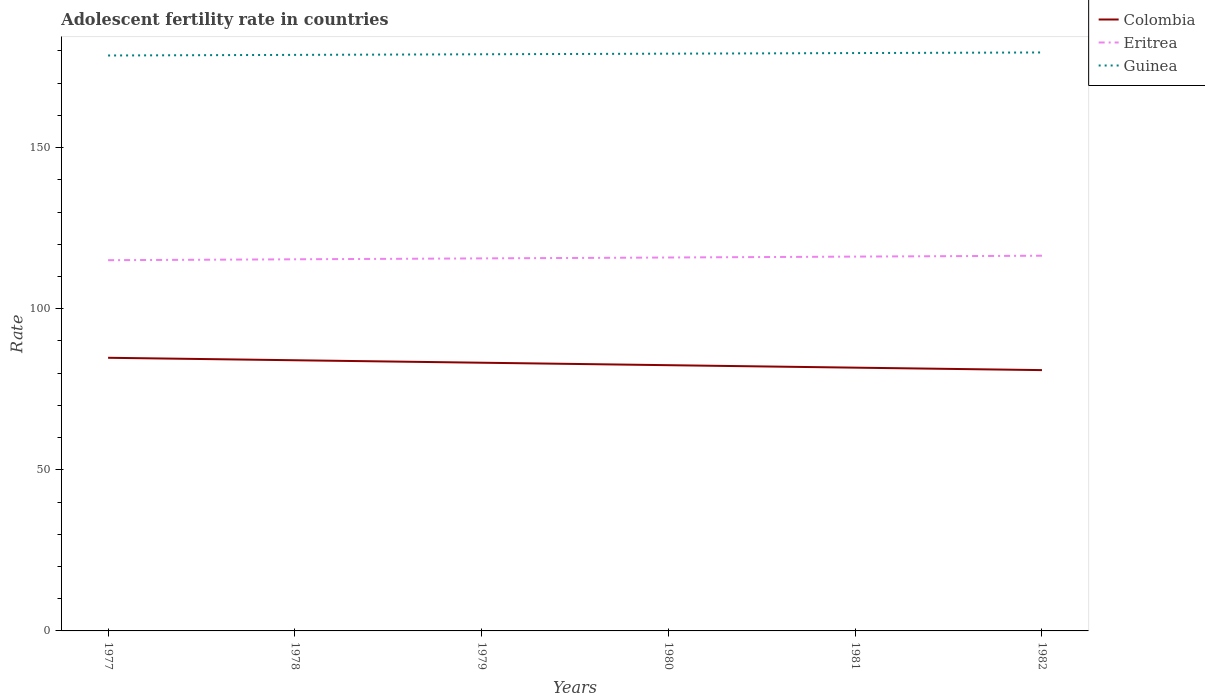How many different coloured lines are there?
Your response must be concise. 3. Does the line corresponding to Eritrea intersect with the line corresponding to Guinea?
Your answer should be very brief. No. Is the number of lines equal to the number of legend labels?
Provide a short and direct response. Yes. Across all years, what is the maximum adolescent fertility rate in Eritrea?
Your answer should be compact. 115.06. What is the total adolescent fertility rate in Colombia in the graph?
Give a very brief answer. 2.3. What is the difference between the highest and the second highest adolescent fertility rate in Guinea?
Keep it short and to the point. 0.94. Is the adolescent fertility rate in Colombia strictly greater than the adolescent fertility rate in Guinea over the years?
Offer a very short reply. Yes. Does the graph contain any zero values?
Offer a terse response. No. How many legend labels are there?
Provide a short and direct response. 3. How are the legend labels stacked?
Offer a terse response. Vertical. What is the title of the graph?
Your answer should be very brief. Adolescent fertility rate in countries. What is the label or title of the X-axis?
Keep it short and to the point. Years. What is the label or title of the Y-axis?
Ensure brevity in your answer.  Rate. What is the Rate in Colombia in 1977?
Make the answer very short. 84.77. What is the Rate in Eritrea in 1977?
Your answer should be very brief. 115.06. What is the Rate in Guinea in 1977?
Your answer should be compact. 178.59. What is the Rate of Colombia in 1978?
Your answer should be very brief. 84. What is the Rate in Eritrea in 1978?
Your response must be concise. 115.33. What is the Rate of Guinea in 1978?
Keep it short and to the point. 178.77. What is the Rate in Colombia in 1979?
Provide a short and direct response. 83.24. What is the Rate of Eritrea in 1979?
Your answer should be very brief. 115.61. What is the Rate of Guinea in 1979?
Your answer should be very brief. 178.96. What is the Rate in Colombia in 1980?
Keep it short and to the point. 82.47. What is the Rate of Eritrea in 1980?
Offer a very short reply. 115.89. What is the Rate of Guinea in 1980?
Provide a short and direct response. 179.15. What is the Rate of Colombia in 1981?
Ensure brevity in your answer.  81.71. What is the Rate in Eritrea in 1981?
Your response must be concise. 116.17. What is the Rate in Guinea in 1981?
Provide a short and direct response. 179.34. What is the Rate in Colombia in 1982?
Provide a short and direct response. 80.94. What is the Rate in Eritrea in 1982?
Provide a short and direct response. 116.45. What is the Rate in Guinea in 1982?
Provide a short and direct response. 179.52. Across all years, what is the maximum Rate in Colombia?
Offer a terse response. 84.77. Across all years, what is the maximum Rate of Eritrea?
Your answer should be compact. 116.45. Across all years, what is the maximum Rate of Guinea?
Offer a very short reply. 179.52. Across all years, what is the minimum Rate of Colombia?
Ensure brevity in your answer.  80.94. Across all years, what is the minimum Rate of Eritrea?
Your answer should be very brief. 115.06. Across all years, what is the minimum Rate in Guinea?
Your answer should be compact. 178.59. What is the total Rate in Colombia in the graph?
Make the answer very short. 497.12. What is the total Rate of Eritrea in the graph?
Offer a terse response. 694.51. What is the total Rate of Guinea in the graph?
Make the answer very short. 1074.33. What is the difference between the Rate of Colombia in 1977 and that in 1978?
Offer a very short reply. 0.77. What is the difference between the Rate in Eritrea in 1977 and that in 1978?
Give a very brief answer. -0.28. What is the difference between the Rate of Guinea in 1977 and that in 1978?
Your answer should be compact. -0.19. What is the difference between the Rate of Colombia in 1977 and that in 1979?
Offer a terse response. 1.53. What is the difference between the Rate of Eritrea in 1977 and that in 1979?
Provide a short and direct response. -0.56. What is the difference between the Rate of Guinea in 1977 and that in 1979?
Offer a terse response. -0.38. What is the difference between the Rate of Colombia in 1977 and that in 1980?
Your answer should be compact. 2.3. What is the difference between the Rate in Eritrea in 1977 and that in 1980?
Give a very brief answer. -0.83. What is the difference between the Rate of Guinea in 1977 and that in 1980?
Provide a succinct answer. -0.56. What is the difference between the Rate of Colombia in 1977 and that in 1981?
Offer a terse response. 3.06. What is the difference between the Rate in Eritrea in 1977 and that in 1981?
Make the answer very short. -1.11. What is the difference between the Rate in Guinea in 1977 and that in 1981?
Offer a very short reply. -0.75. What is the difference between the Rate of Colombia in 1977 and that in 1982?
Give a very brief answer. 3.83. What is the difference between the Rate in Eritrea in 1977 and that in 1982?
Keep it short and to the point. -1.39. What is the difference between the Rate of Guinea in 1977 and that in 1982?
Offer a terse response. -0.94. What is the difference between the Rate of Colombia in 1978 and that in 1979?
Offer a very short reply. 0.77. What is the difference between the Rate in Eritrea in 1978 and that in 1979?
Provide a short and direct response. -0.28. What is the difference between the Rate of Guinea in 1978 and that in 1979?
Your answer should be compact. -0.19. What is the difference between the Rate in Colombia in 1978 and that in 1980?
Give a very brief answer. 1.53. What is the difference between the Rate of Eritrea in 1978 and that in 1980?
Provide a short and direct response. -0.56. What is the difference between the Rate in Guinea in 1978 and that in 1980?
Your answer should be compact. -0.38. What is the difference between the Rate in Colombia in 1978 and that in 1981?
Ensure brevity in your answer.  2.3. What is the difference between the Rate of Eritrea in 1978 and that in 1981?
Ensure brevity in your answer.  -0.83. What is the difference between the Rate of Guinea in 1978 and that in 1981?
Your answer should be compact. -0.56. What is the difference between the Rate in Colombia in 1978 and that in 1982?
Give a very brief answer. 3.06. What is the difference between the Rate in Eritrea in 1978 and that in 1982?
Keep it short and to the point. -1.11. What is the difference between the Rate of Guinea in 1978 and that in 1982?
Offer a very short reply. -0.75. What is the difference between the Rate of Colombia in 1979 and that in 1980?
Offer a terse response. 0.77. What is the difference between the Rate of Eritrea in 1979 and that in 1980?
Provide a succinct answer. -0.28. What is the difference between the Rate in Guinea in 1979 and that in 1980?
Offer a terse response. -0.19. What is the difference between the Rate of Colombia in 1979 and that in 1981?
Offer a very short reply. 1.53. What is the difference between the Rate in Eritrea in 1979 and that in 1981?
Make the answer very short. -0.56. What is the difference between the Rate of Guinea in 1979 and that in 1981?
Your response must be concise. -0.38. What is the difference between the Rate in Colombia in 1979 and that in 1982?
Offer a very short reply. 2.3. What is the difference between the Rate of Eritrea in 1979 and that in 1982?
Provide a succinct answer. -0.83. What is the difference between the Rate of Guinea in 1979 and that in 1982?
Make the answer very short. -0.56. What is the difference between the Rate in Colombia in 1980 and that in 1981?
Offer a very short reply. 0.77. What is the difference between the Rate of Eritrea in 1980 and that in 1981?
Provide a short and direct response. -0.28. What is the difference between the Rate of Guinea in 1980 and that in 1981?
Your answer should be compact. -0.19. What is the difference between the Rate of Colombia in 1980 and that in 1982?
Offer a very short reply. 1.53. What is the difference between the Rate in Eritrea in 1980 and that in 1982?
Give a very brief answer. -0.56. What is the difference between the Rate in Guinea in 1980 and that in 1982?
Offer a very short reply. -0.38. What is the difference between the Rate of Colombia in 1981 and that in 1982?
Keep it short and to the point. 0.77. What is the difference between the Rate of Eritrea in 1981 and that in 1982?
Give a very brief answer. -0.28. What is the difference between the Rate of Guinea in 1981 and that in 1982?
Keep it short and to the point. -0.19. What is the difference between the Rate of Colombia in 1977 and the Rate of Eritrea in 1978?
Your response must be concise. -30.57. What is the difference between the Rate in Colombia in 1977 and the Rate in Guinea in 1978?
Give a very brief answer. -94.01. What is the difference between the Rate in Eritrea in 1977 and the Rate in Guinea in 1978?
Make the answer very short. -63.72. What is the difference between the Rate of Colombia in 1977 and the Rate of Eritrea in 1979?
Your response must be concise. -30.84. What is the difference between the Rate in Colombia in 1977 and the Rate in Guinea in 1979?
Make the answer very short. -94.19. What is the difference between the Rate in Eritrea in 1977 and the Rate in Guinea in 1979?
Offer a terse response. -63.9. What is the difference between the Rate of Colombia in 1977 and the Rate of Eritrea in 1980?
Keep it short and to the point. -31.12. What is the difference between the Rate in Colombia in 1977 and the Rate in Guinea in 1980?
Offer a very short reply. -94.38. What is the difference between the Rate of Eritrea in 1977 and the Rate of Guinea in 1980?
Offer a very short reply. -64.09. What is the difference between the Rate in Colombia in 1977 and the Rate in Eritrea in 1981?
Your answer should be compact. -31.4. What is the difference between the Rate in Colombia in 1977 and the Rate in Guinea in 1981?
Keep it short and to the point. -94.57. What is the difference between the Rate in Eritrea in 1977 and the Rate in Guinea in 1981?
Make the answer very short. -64.28. What is the difference between the Rate in Colombia in 1977 and the Rate in Eritrea in 1982?
Make the answer very short. -31.68. What is the difference between the Rate of Colombia in 1977 and the Rate of Guinea in 1982?
Keep it short and to the point. -94.76. What is the difference between the Rate of Eritrea in 1977 and the Rate of Guinea in 1982?
Your answer should be compact. -64.47. What is the difference between the Rate of Colombia in 1978 and the Rate of Eritrea in 1979?
Keep it short and to the point. -31.61. What is the difference between the Rate in Colombia in 1978 and the Rate in Guinea in 1979?
Ensure brevity in your answer.  -94.96. What is the difference between the Rate of Eritrea in 1978 and the Rate of Guinea in 1979?
Your answer should be very brief. -63.63. What is the difference between the Rate in Colombia in 1978 and the Rate in Eritrea in 1980?
Make the answer very short. -31.89. What is the difference between the Rate of Colombia in 1978 and the Rate of Guinea in 1980?
Offer a terse response. -95.15. What is the difference between the Rate of Eritrea in 1978 and the Rate of Guinea in 1980?
Your answer should be very brief. -63.81. What is the difference between the Rate in Colombia in 1978 and the Rate in Eritrea in 1981?
Your answer should be compact. -32.17. What is the difference between the Rate in Colombia in 1978 and the Rate in Guinea in 1981?
Offer a very short reply. -95.33. What is the difference between the Rate of Eritrea in 1978 and the Rate of Guinea in 1981?
Your answer should be compact. -64. What is the difference between the Rate in Colombia in 1978 and the Rate in Eritrea in 1982?
Your answer should be very brief. -32.44. What is the difference between the Rate of Colombia in 1978 and the Rate of Guinea in 1982?
Provide a succinct answer. -95.52. What is the difference between the Rate of Eritrea in 1978 and the Rate of Guinea in 1982?
Your answer should be very brief. -64.19. What is the difference between the Rate of Colombia in 1979 and the Rate of Eritrea in 1980?
Provide a short and direct response. -32.65. What is the difference between the Rate in Colombia in 1979 and the Rate in Guinea in 1980?
Keep it short and to the point. -95.91. What is the difference between the Rate in Eritrea in 1979 and the Rate in Guinea in 1980?
Provide a succinct answer. -63.54. What is the difference between the Rate in Colombia in 1979 and the Rate in Eritrea in 1981?
Provide a succinct answer. -32.93. What is the difference between the Rate of Colombia in 1979 and the Rate of Guinea in 1981?
Offer a very short reply. -96.1. What is the difference between the Rate in Eritrea in 1979 and the Rate in Guinea in 1981?
Make the answer very short. -63.72. What is the difference between the Rate of Colombia in 1979 and the Rate of Eritrea in 1982?
Ensure brevity in your answer.  -33.21. What is the difference between the Rate in Colombia in 1979 and the Rate in Guinea in 1982?
Ensure brevity in your answer.  -96.29. What is the difference between the Rate in Eritrea in 1979 and the Rate in Guinea in 1982?
Your response must be concise. -63.91. What is the difference between the Rate in Colombia in 1980 and the Rate in Eritrea in 1981?
Provide a short and direct response. -33.7. What is the difference between the Rate in Colombia in 1980 and the Rate in Guinea in 1981?
Offer a very short reply. -96.87. What is the difference between the Rate in Eritrea in 1980 and the Rate in Guinea in 1981?
Offer a terse response. -63.45. What is the difference between the Rate of Colombia in 1980 and the Rate of Eritrea in 1982?
Give a very brief answer. -33.98. What is the difference between the Rate of Colombia in 1980 and the Rate of Guinea in 1982?
Keep it short and to the point. -97.05. What is the difference between the Rate of Eritrea in 1980 and the Rate of Guinea in 1982?
Your answer should be compact. -63.63. What is the difference between the Rate of Colombia in 1981 and the Rate of Eritrea in 1982?
Ensure brevity in your answer.  -34.74. What is the difference between the Rate in Colombia in 1981 and the Rate in Guinea in 1982?
Provide a short and direct response. -97.82. What is the difference between the Rate of Eritrea in 1981 and the Rate of Guinea in 1982?
Your answer should be very brief. -63.36. What is the average Rate of Colombia per year?
Offer a very short reply. 82.85. What is the average Rate of Eritrea per year?
Your answer should be very brief. 115.75. What is the average Rate of Guinea per year?
Provide a short and direct response. 179.05. In the year 1977, what is the difference between the Rate in Colombia and Rate in Eritrea?
Keep it short and to the point. -30.29. In the year 1977, what is the difference between the Rate of Colombia and Rate of Guinea?
Offer a terse response. -93.82. In the year 1977, what is the difference between the Rate of Eritrea and Rate of Guinea?
Offer a terse response. -63.53. In the year 1978, what is the difference between the Rate in Colombia and Rate in Eritrea?
Make the answer very short. -31.33. In the year 1978, what is the difference between the Rate in Colombia and Rate in Guinea?
Provide a succinct answer. -94.77. In the year 1978, what is the difference between the Rate of Eritrea and Rate of Guinea?
Make the answer very short. -63.44. In the year 1979, what is the difference between the Rate of Colombia and Rate of Eritrea?
Your answer should be compact. -32.38. In the year 1979, what is the difference between the Rate of Colombia and Rate of Guinea?
Ensure brevity in your answer.  -95.72. In the year 1979, what is the difference between the Rate in Eritrea and Rate in Guinea?
Ensure brevity in your answer.  -63.35. In the year 1980, what is the difference between the Rate in Colombia and Rate in Eritrea?
Your response must be concise. -33.42. In the year 1980, what is the difference between the Rate in Colombia and Rate in Guinea?
Your answer should be compact. -96.68. In the year 1980, what is the difference between the Rate of Eritrea and Rate of Guinea?
Keep it short and to the point. -63.26. In the year 1981, what is the difference between the Rate of Colombia and Rate of Eritrea?
Make the answer very short. -34.46. In the year 1981, what is the difference between the Rate of Colombia and Rate of Guinea?
Provide a succinct answer. -97.63. In the year 1981, what is the difference between the Rate of Eritrea and Rate of Guinea?
Keep it short and to the point. -63.17. In the year 1982, what is the difference between the Rate of Colombia and Rate of Eritrea?
Keep it short and to the point. -35.51. In the year 1982, what is the difference between the Rate in Colombia and Rate in Guinea?
Offer a terse response. -98.58. In the year 1982, what is the difference between the Rate in Eritrea and Rate in Guinea?
Ensure brevity in your answer.  -63.08. What is the ratio of the Rate in Colombia in 1977 to that in 1978?
Your answer should be compact. 1.01. What is the ratio of the Rate of Guinea in 1977 to that in 1978?
Your answer should be very brief. 1. What is the ratio of the Rate in Colombia in 1977 to that in 1979?
Ensure brevity in your answer.  1.02. What is the ratio of the Rate in Eritrea in 1977 to that in 1979?
Your answer should be very brief. 1. What is the ratio of the Rate of Colombia in 1977 to that in 1980?
Ensure brevity in your answer.  1.03. What is the ratio of the Rate in Eritrea in 1977 to that in 1980?
Your answer should be compact. 0.99. What is the ratio of the Rate of Colombia in 1977 to that in 1981?
Provide a short and direct response. 1.04. What is the ratio of the Rate of Eritrea in 1977 to that in 1981?
Keep it short and to the point. 0.99. What is the ratio of the Rate of Guinea in 1977 to that in 1981?
Make the answer very short. 1. What is the ratio of the Rate in Colombia in 1977 to that in 1982?
Offer a terse response. 1.05. What is the ratio of the Rate of Guinea in 1977 to that in 1982?
Provide a short and direct response. 0.99. What is the ratio of the Rate of Colombia in 1978 to that in 1979?
Make the answer very short. 1.01. What is the ratio of the Rate in Guinea in 1978 to that in 1979?
Offer a very short reply. 1. What is the ratio of the Rate of Colombia in 1978 to that in 1980?
Offer a terse response. 1.02. What is the ratio of the Rate in Eritrea in 1978 to that in 1980?
Ensure brevity in your answer.  1. What is the ratio of the Rate of Guinea in 1978 to that in 1980?
Make the answer very short. 1. What is the ratio of the Rate in Colombia in 1978 to that in 1981?
Offer a very short reply. 1.03. What is the ratio of the Rate in Colombia in 1978 to that in 1982?
Ensure brevity in your answer.  1.04. What is the ratio of the Rate of Eritrea in 1978 to that in 1982?
Keep it short and to the point. 0.99. What is the ratio of the Rate in Colombia in 1979 to that in 1980?
Your answer should be compact. 1.01. What is the ratio of the Rate in Eritrea in 1979 to that in 1980?
Your response must be concise. 1. What is the ratio of the Rate in Colombia in 1979 to that in 1981?
Make the answer very short. 1.02. What is the ratio of the Rate in Eritrea in 1979 to that in 1981?
Ensure brevity in your answer.  1. What is the ratio of the Rate in Colombia in 1979 to that in 1982?
Give a very brief answer. 1.03. What is the ratio of the Rate in Eritrea in 1979 to that in 1982?
Your response must be concise. 0.99. What is the ratio of the Rate in Colombia in 1980 to that in 1981?
Your answer should be very brief. 1.01. What is the ratio of the Rate of Colombia in 1980 to that in 1982?
Your answer should be compact. 1.02. What is the ratio of the Rate in Guinea in 1980 to that in 1982?
Ensure brevity in your answer.  1. What is the ratio of the Rate of Colombia in 1981 to that in 1982?
Your response must be concise. 1.01. What is the ratio of the Rate in Eritrea in 1981 to that in 1982?
Ensure brevity in your answer.  1. What is the ratio of the Rate in Guinea in 1981 to that in 1982?
Make the answer very short. 1. What is the difference between the highest and the second highest Rate of Colombia?
Offer a terse response. 0.77. What is the difference between the highest and the second highest Rate in Eritrea?
Give a very brief answer. 0.28. What is the difference between the highest and the second highest Rate in Guinea?
Offer a terse response. 0.19. What is the difference between the highest and the lowest Rate of Colombia?
Provide a succinct answer. 3.83. What is the difference between the highest and the lowest Rate in Eritrea?
Offer a terse response. 1.39. What is the difference between the highest and the lowest Rate in Guinea?
Your answer should be compact. 0.94. 